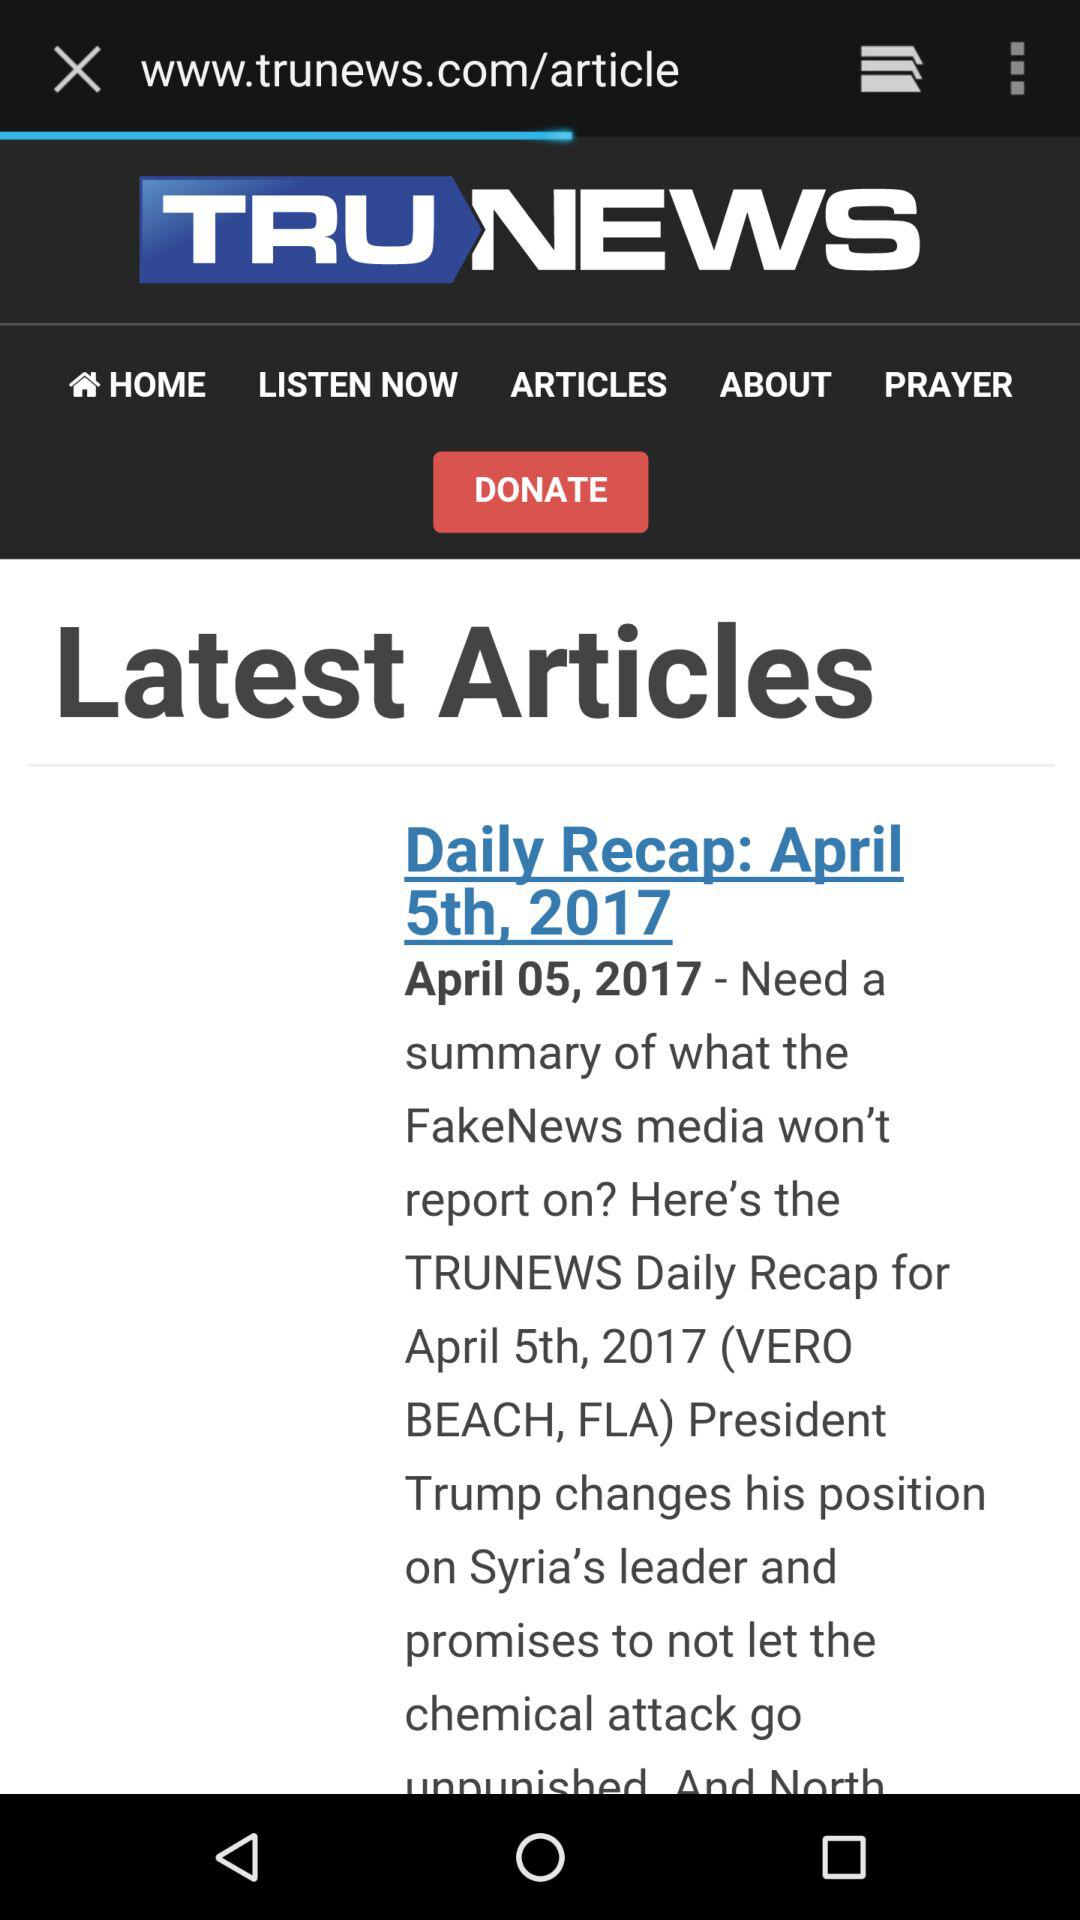From what country did President Trump promise to not let the chemical attack go? The country is Syria. 